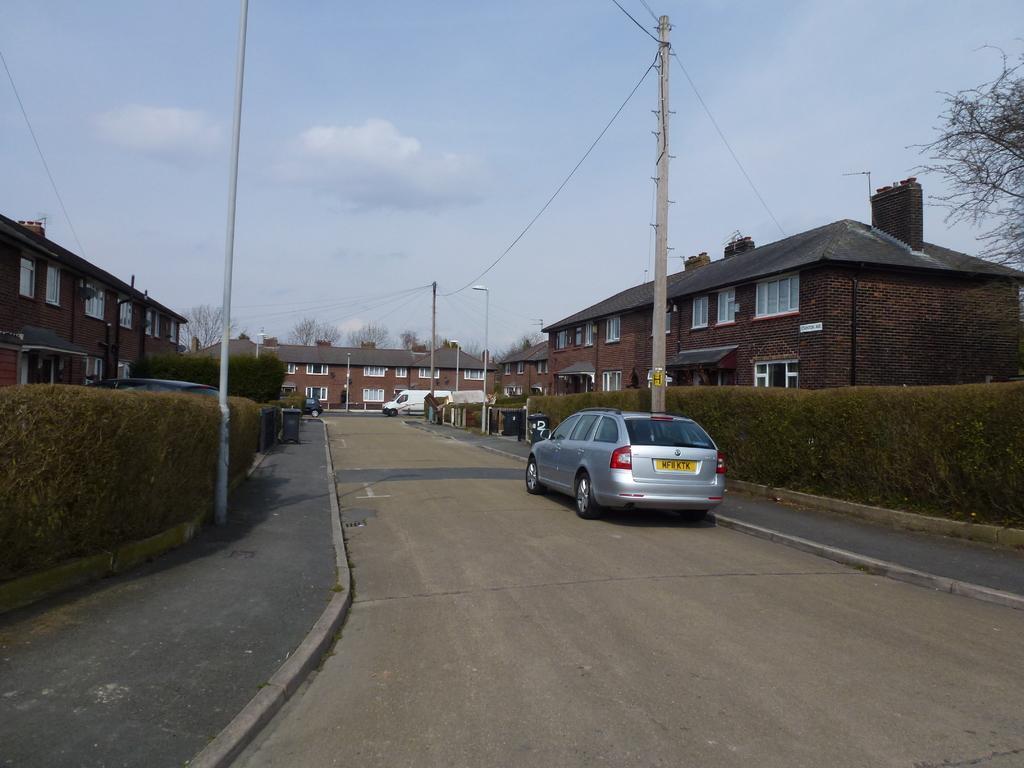Please provide a concise description of this image. This picture shows a few buildings and we see trees and few cars on the road and we see poles and a pole light and a blue cloudy Sky. 